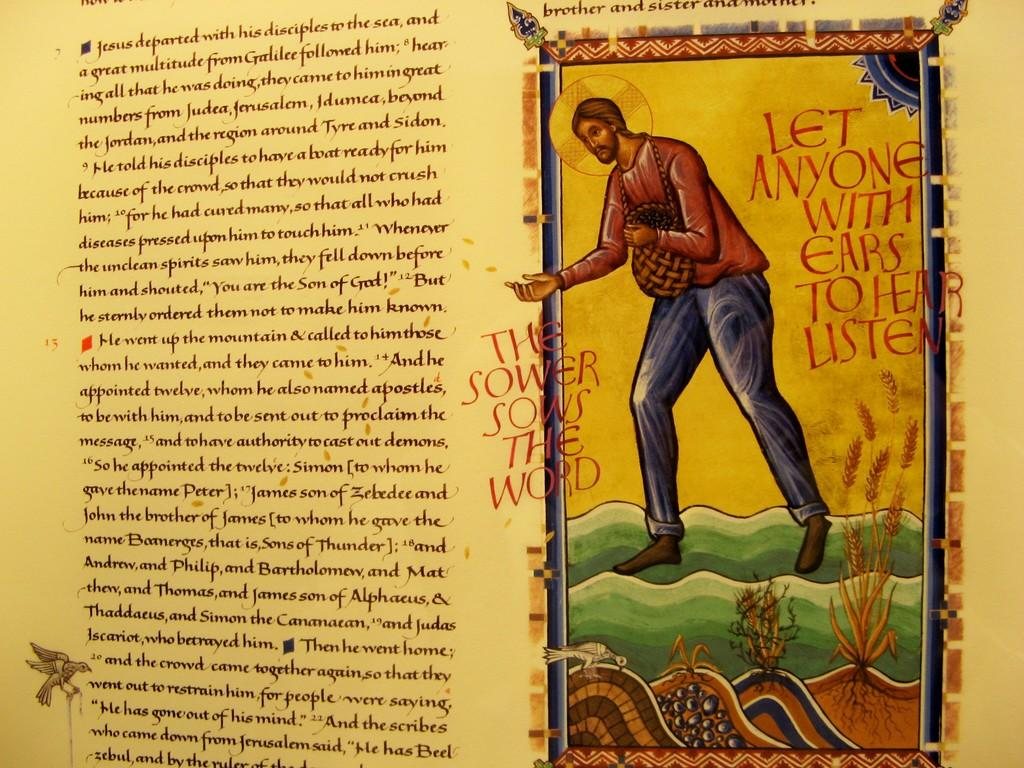What is present in the image along with the person? There is a bird in the image along with the person. What type of natural environment can be seen in the image? There is grass in the image, indicating a natural environment. What is the nature of the text or writing in the image? The image contains text or writing, but we cannot determine its content from the facts provided. How would you describe the overall appearance of the image? The image is colorful, making it visually appealing. What type of metal is used to make the yoke in the image? There is no yoke present in the image, so we cannot determine the type of metal used to make it. 